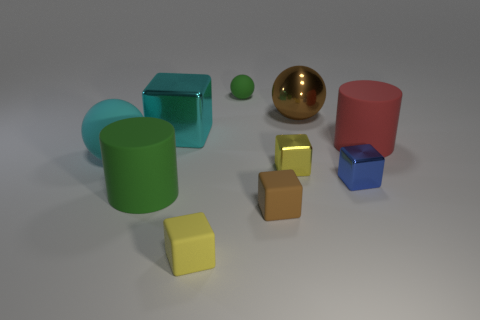Subtract all cyan blocks. How many blocks are left? 4 Subtract all brown matte blocks. How many blocks are left? 4 Subtract all gray cubes. Subtract all yellow balls. How many cubes are left? 5 Subtract all spheres. How many objects are left? 7 Subtract all tiny rubber balls. Subtract all small yellow things. How many objects are left? 7 Add 2 blue blocks. How many blue blocks are left? 3 Add 9 big brown balls. How many big brown balls exist? 10 Subtract 1 brown blocks. How many objects are left? 9 